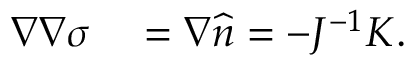Convert formula to latex. <formula><loc_0><loc_0><loc_500><loc_500>\begin{array} { r l } { \nabla \nabla \sigma } & = \nabla \widehat { n } = - J ^ { - 1 } K . } \end{array}</formula> 